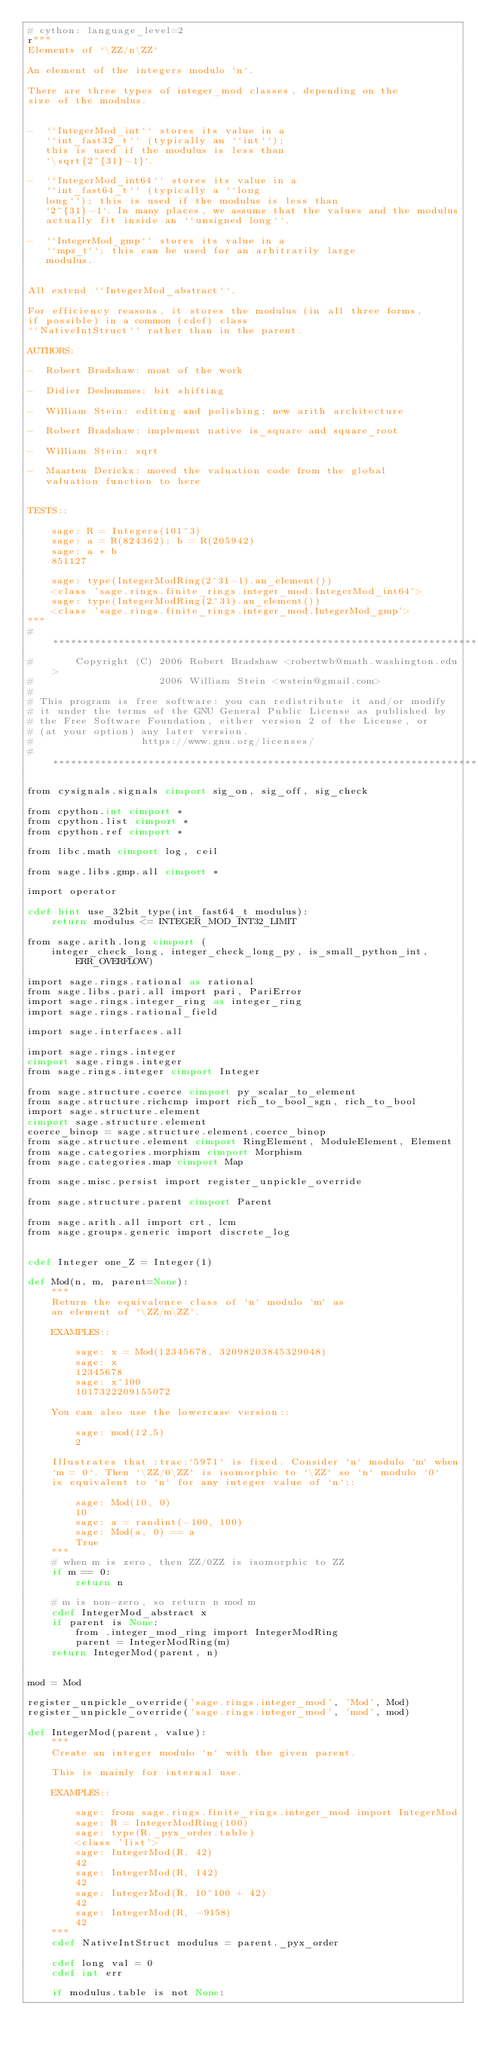<code> <loc_0><loc_0><loc_500><loc_500><_Cython_># cython: language_level=2
r"""
Elements of `\ZZ/n\ZZ`

An element of the integers modulo `n`.

There are three types of integer_mod classes, depending on the
size of the modulus.


-  ``IntegerMod_int`` stores its value in a
   ``int_fast32_t`` (typically an ``int``);
   this is used if the modulus is less than
   `\sqrt{2^{31}-1}`.

-  ``IntegerMod_int64`` stores its value in a
   ``int_fast64_t`` (typically a ``long
   long``); this is used if the modulus is less than
   `2^{31}-1`. In many places, we assume that the values and the modulus
   actually fit inside an ``unsigned long``.

-  ``IntegerMod_gmp`` stores its value in a
   ``mpz_t``; this can be used for an arbitrarily large
   modulus.


All extend ``IntegerMod_abstract``.

For efficiency reasons, it stores the modulus (in all three forms,
if possible) in a common (cdef) class
``NativeIntStruct`` rather than in the parent.

AUTHORS:

-  Robert Bradshaw: most of the work

-  Didier Deshommes: bit shifting

-  William Stein: editing and polishing; new arith architecture

-  Robert Bradshaw: implement native is_square and square_root

-  William Stein: sqrt

-  Maarten Derickx: moved the valuation code from the global
   valuation function to here


TESTS::

    sage: R = Integers(101^3)
    sage: a = R(824362); b = R(205942)
    sage: a * b
    851127

    sage: type(IntegerModRing(2^31-1).an_element())
    <class 'sage.rings.finite_rings.integer_mod.IntegerMod_int64'>
    sage: type(IntegerModRing(2^31).an_element())
    <class 'sage.rings.finite_rings.integer_mod.IntegerMod_gmp'>
"""
# ****************************************************************************
#       Copyright (C) 2006 Robert Bradshaw <robertwb@math.washington.edu>
#                     2006 William Stein <wstein@gmail.com>
#
# This program is free software: you can redistribute it and/or modify
# it under the terms of the GNU General Public License as published by
# the Free Software Foundation, either version 2 of the License, or
# (at your option) any later version.
#                  https://www.gnu.org/licenses/
# ****************************************************************************

from cysignals.signals cimport sig_on, sig_off, sig_check

from cpython.int cimport *
from cpython.list cimport *
from cpython.ref cimport *

from libc.math cimport log, ceil

from sage.libs.gmp.all cimport *

import operator

cdef bint use_32bit_type(int_fast64_t modulus):
    return modulus <= INTEGER_MOD_INT32_LIMIT

from sage.arith.long cimport (
    integer_check_long, integer_check_long_py, is_small_python_int, ERR_OVERFLOW)

import sage.rings.rational as rational
from sage.libs.pari.all import pari, PariError
import sage.rings.integer_ring as integer_ring
import sage.rings.rational_field

import sage.interfaces.all

import sage.rings.integer
cimport sage.rings.integer
from sage.rings.integer cimport Integer

from sage.structure.coerce cimport py_scalar_to_element
from sage.structure.richcmp import rich_to_bool_sgn, rich_to_bool
import sage.structure.element
cimport sage.structure.element
coerce_binop = sage.structure.element.coerce_binop
from sage.structure.element cimport RingElement, ModuleElement, Element
from sage.categories.morphism cimport Morphism
from sage.categories.map cimport Map

from sage.misc.persist import register_unpickle_override

from sage.structure.parent cimport Parent

from sage.arith.all import crt, lcm
from sage.groups.generic import discrete_log


cdef Integer one_Z = Integer(1)

def Mod(n, m, parent=None):
    """
    Return the equivalence class of `n` modulo `m` as
    an element of `\ZZ/m\ZZ`.

    EXAMPLES::

        sage: x = Mod(12345678, 32098203845329048)
        sage: x
        12345678
        sage: x^100
        1017322209155072

    You can also use the lowercase version::

        sage: mod(12,5)
        2

    Illustrates that :trac:`5971` is fixed. Consider `n` modulo `m` when
    `m = 0`. Then `\ZZ/0\ZZ` is isomorphic to `\ZZ` so `n` modulo `0`
    is equivalent to `n` for any integer value of `n`::

        sage: Mod(10, 0)
        10
        sage: a = randint(-100, 100)
        sage: Mod(a, 0) == a
        True
    """
    # when m is zero, then ZZ/0ZZ is isomorphic to ZZ
    if m == 0:
        return n

    # m is non-zero, so return n mod m
    cdef IntegerMod_abstract x
    if parent is None:
        from .integer_mod_ring import IntegerModRing
        parent = IntegerModRing(m)
    return IntegerMod(parent, n)


mod = Mod

register_unpickle_override('sage.rings.integer_mod', 'Mod', Mod)
register_unpickle_override('sage.rings.integer_mod', 'mod', mod)

def IntegerMod(parent, value):
    """
    Create an integer modulo `n` with the given parent.

    This is mainly for internal use.

    EXAMPLES::

        sage: from sage.rings.finite_rings.integer_mod import IntegerMod
        sage: R = IntegerModRing(100)
        sage: type(R._pyx_order.table)
        <class 'list'>
        sage: IntegerMod(R, 42)
        42
        sage: IntegerMod(R, 142)
        42
        sage: IntegerMod(R, 10^100 + 42)
        42
        sage: IntegerMod(R, -9158)
        42
    """
    cdef NativeIntStruct modulus = parent._pyx_order

    cdef long val = 0
    cdef int err

    if modulus.table is not None:</code> 